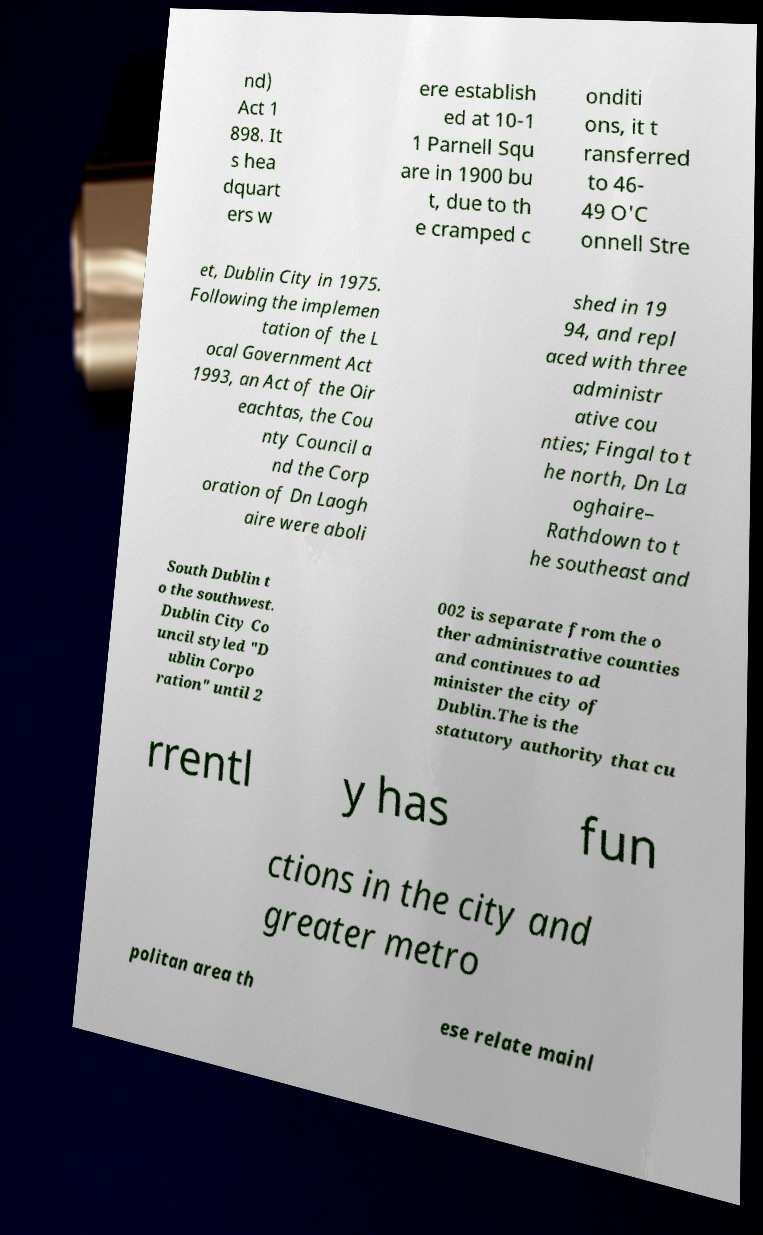For documentation purposes, I need the text within this image transcribed. Could you provide that? nd) Act 1 898. It s hea dquart ers w ere establish ed at 10-1 1 Parnell Squ are in 1900 bu t, due to th e cramped c onditi ons, it t ransferred to 46- 49 O'C onnell Stre et, Dublin City in 1975. Following the implemen tation of the L ocal Government Act 1993, an Act of the Oir eachtas, the Cou nty Council a nd the Corp oration of Dn Laogh aire were aboli shed in 19 94, and repl aced with three administr ative cou nties; Fingal to t he north, Dn La oghaire– Rathdown to t he southeast and South Dublin t o the southwest. Dublin City Co uncil styled "D ublin Corpo ration" until 2 002 is separate from the o ther administrative counties and continues to ad minister the city of Dublin.The is the statutory authority that cu rrentl y has fun ctions in the city and greater metro politan area th ese relate mainl 